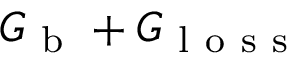<formula> <loc_0><loc_0><loc_500><loc_500>G _ { b } + G _ { l o s s }</formula> 